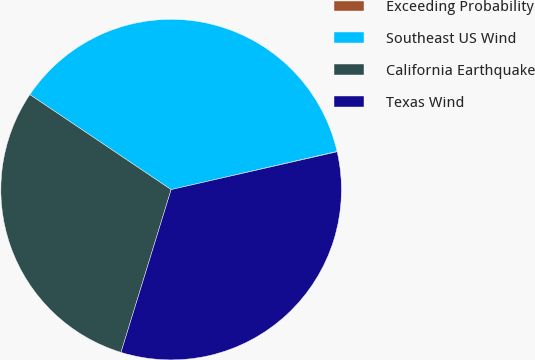Convert chart to OTSL. <chart><loc_0><loc_0><loc_500><loc_500><pie_chart><fcel>Exceeding Probability<fcel>Southeast US Wind<fcel>California Earthquake<fcel>Texas Wind<nl><fcel>0.04%<fcel>36.97%<fcel>29.67%<fcel>33.32%<nl></chart> 